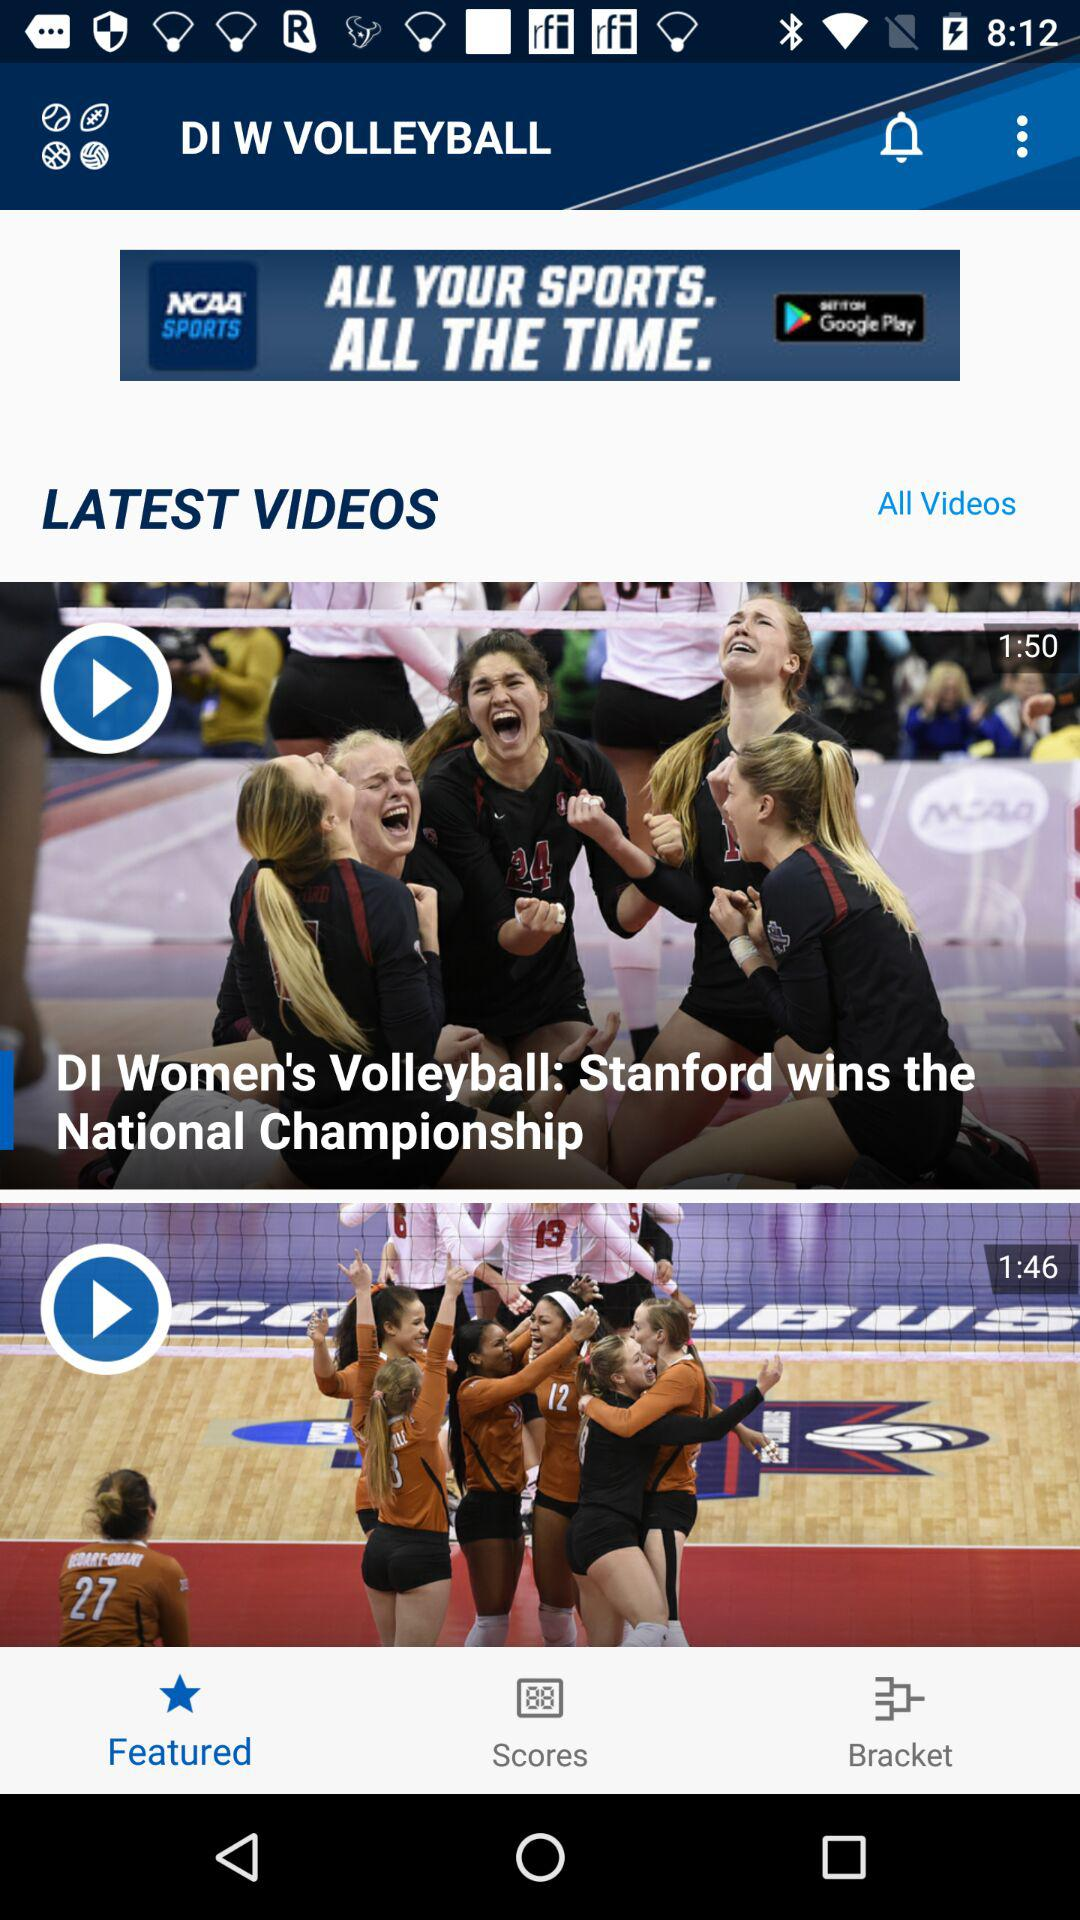Which teams are in the bracket?
When the provided information is insufficient, respond with <no answer>. <no answer> 